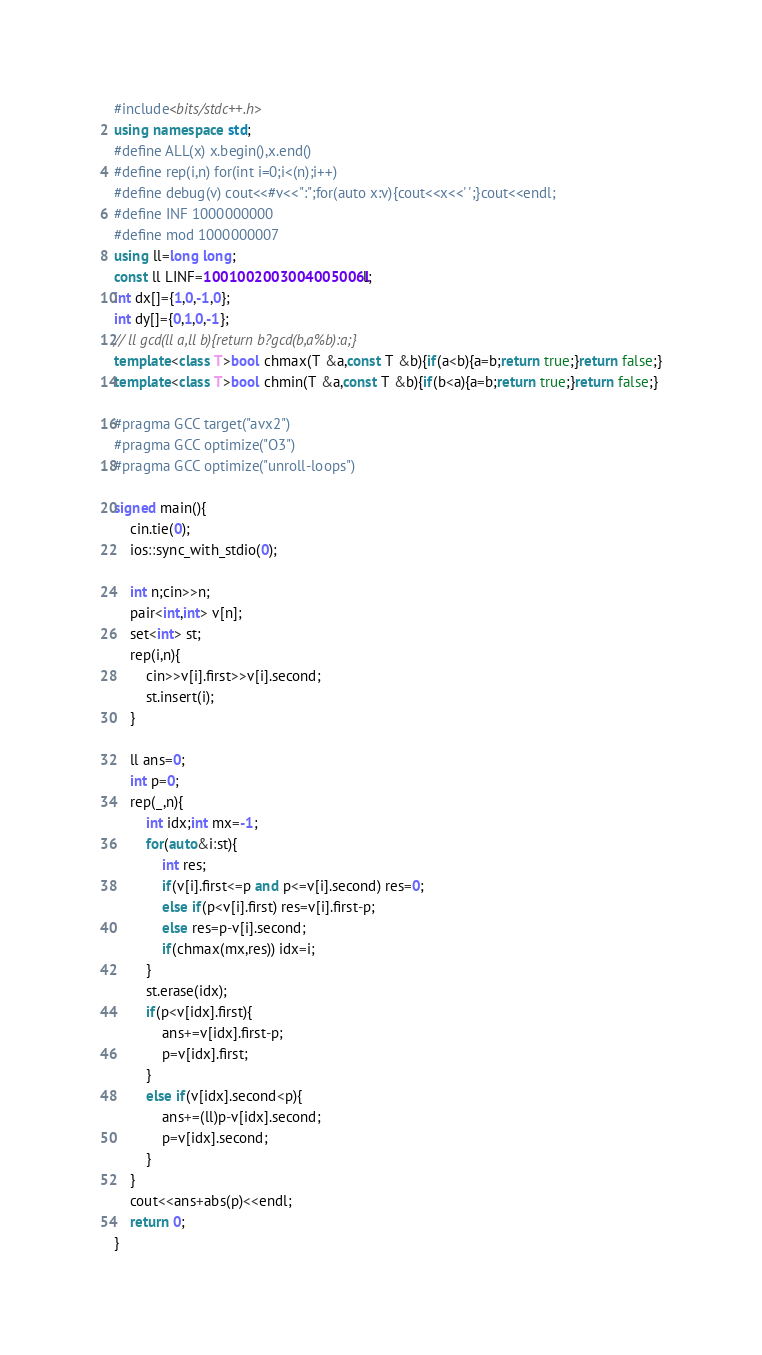<code> <loc_0><loc_0><loc_500><loc_500><_C++_>#include<bits/stdc++.h>
using namespace std;
#define ALL(x) x.begin(),x.end()
#define rep(i,n) for(int i=0;i<(n);i++)
#define debug(v) cout<<#v<<":";for(auto x:v){cout<<x<<' ';}cout<<endl;
#define INF 1000000000
#define mod 1000000007
using ll=long long;
const ll LINF=1001002003004005006ll;
int dx[]={1,0,-1,0};
int dy[]={0,1,0,-1};
// ll gcd(ll a,ll b){return b?gcd(b,a%b):a;}
template<class T>bool chmax(T &a,const T &b){if(a<b){a=b;return true;}return false;}
template<class T>bool chmin(T &a,const T &b){if(b<a){a=b;return true;}return false;}

#pragma GCC target("avx2")
#pragma GCC optimize("O3")
#pragma GCC optimize("unroll-loops")

signed main(){
    cin.tie(0);
    ios::sync_with_stdio(0);
    
    int n;cin>>n;
    pair<int,int> v[n];
    set<int> st;
    rep(i,n){
        cin>>v[i].first>>v[i].second;
        st.insert(i);
    }

    ll ans=0;
    int p=0;
    rep(_,n){
        int idx;int mx=-1;
        for(auto&i:st){
            int res;
            if(v[i].first<=p and p<=v[i].second) res=0;
            else if(p<v[i].first) res=v[i].first-p;
            else res=p-v[i].second;   
            if(chmax(mx,res)) idx=i;
        }
        st.erase(idx);
        if(p<v[idx].first){
            ans+=v[idx].first-p;
            p=v[idx].first;
        }
        else if(v[idx].second<p){
            ans+=(ll)p-v[idx].second;
            p=v[idx].second;
        }
    }
    cout<<ans+abs(p)<<endl;
    return 0;
}
</code> 